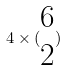<formula> <loc_0><loc_0><loc_500><loc_500>4 \times ( \begin{matrix} 6 \\ 2 \end{matrix} )</formula> 